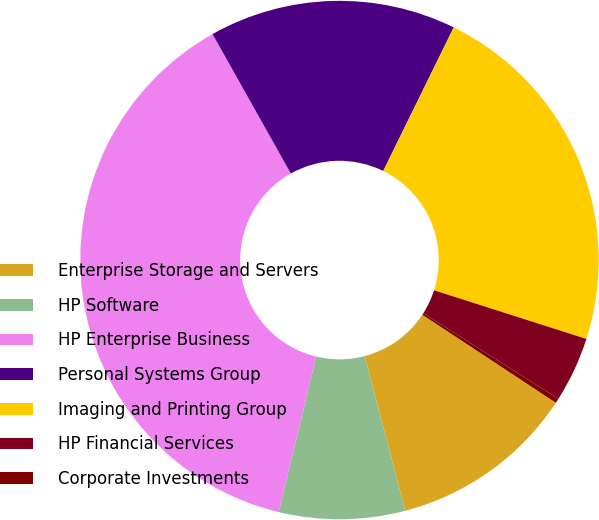Convert chart. <chart><loc_0><loc_0><loc_500><loc_500><pie_chart><fcel>Enterprise Storage and Servers<fcel>HP Software<fcel>HP Enterprise Business<fcel>Personal Systems Group<fcel>Imaging and Printing Group<fcel>HP Financial Services<fcel>Corporate Investments<nl><fcel>11.63%<fcel>7.85%<fcel>38.08%<fcel>15.41%<fcel>22.65%<fcel>4.07%<fcel>0.29%<nl></chart> 